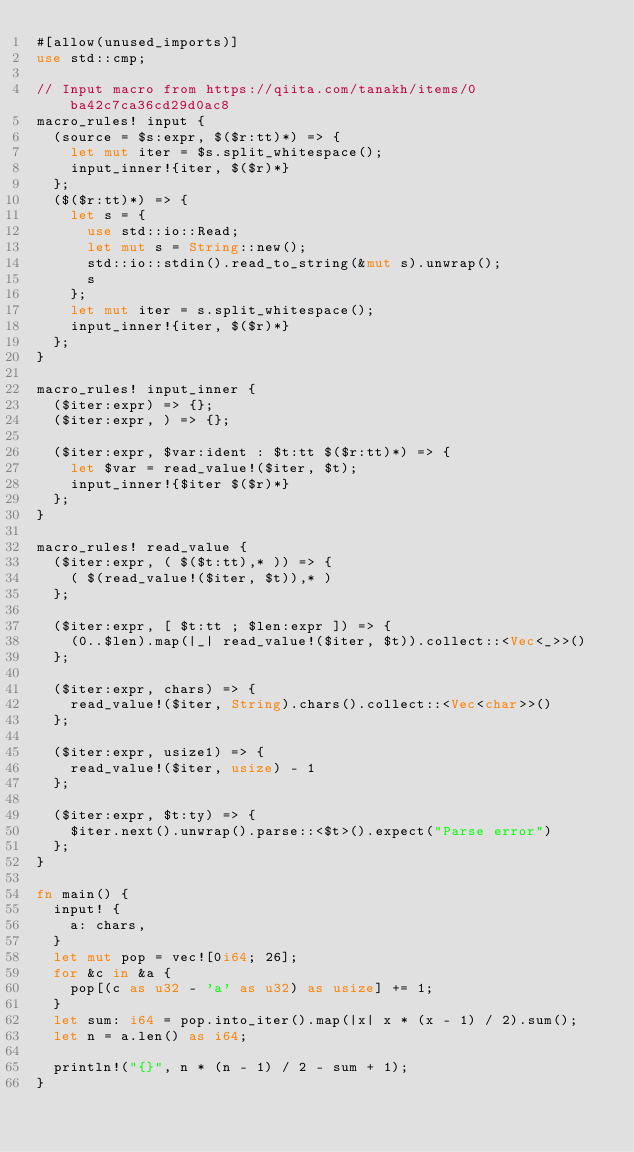Convert code to text. <code><loc_0><loc_0><loc_500><loc_500><_Rust_>#[allow(unused_imports)]
use std::cmp;

// Input macro from https://qiita.com/tanakh/items/0ba42c7ca36cd29d0ac8
macro_rules! input {
  (source = $s:expr, $($r:tt)*) => {
    let mut iter = $s.split_whitespace();
    input_inner!{iter, $($r)*}
  };
  ($($r:tt)*) => {
    let s = {
      use std::io::Read;
      let mut s = String::new();
      std::io::stdin().read_to_string(&mut s).unwrap();
      s
    };
    let mut iter = s.split_whitespace();
    input_inner!{iter, $($r)*}
  };
}

macro_rules! input_inner {
  ($iter:expr) => {};
  ($iter:expr, ) => {};

  ($iter:expr, $var:ident : $t:tt $($r:tt)*) => {
    let $var = read_value!($iter, $t);
    input_inner!{$iter $($r)*}
  };
}

macro_rules! read_value {
  ($iter:expr, ( $($t:tt),* )) => {
    ( $(read_value!($iter, $t)),* )
  };

  ($iter:expr, [ $t:tt ; $len:expr ]) => {
    (0..$len).map(|_| read_value!($iter, $t)).collect::<Vec<_>>()
  };

  ($iter:expr, chars) => {
    read_value!($iter, String).chars().collect::<Vec<char>>()
  };

  ($iter:expr, usize1) => {
    read_value!($iter, usize) - 1
  };

  ($iter:expr, $t:ty) => {
    $iter.next().unwrap().parse::<$t>().expect("Parse error")
  };
}

fn main() {
  input! {
    a: chars,
  }
  let mut pop = vec![0i64; 26];
  for &c in &a {
    pop[(c as u32 - 'a' as u32) as usize] += 1;
  }
  let sum: i64 = pop.into_iter().map(|x| x * (x - 1) / 2).sum();
  let n = a.len() as i64;

  println!("{}", n * (n - 1) / 2 - sum + 1);
}
</code> 